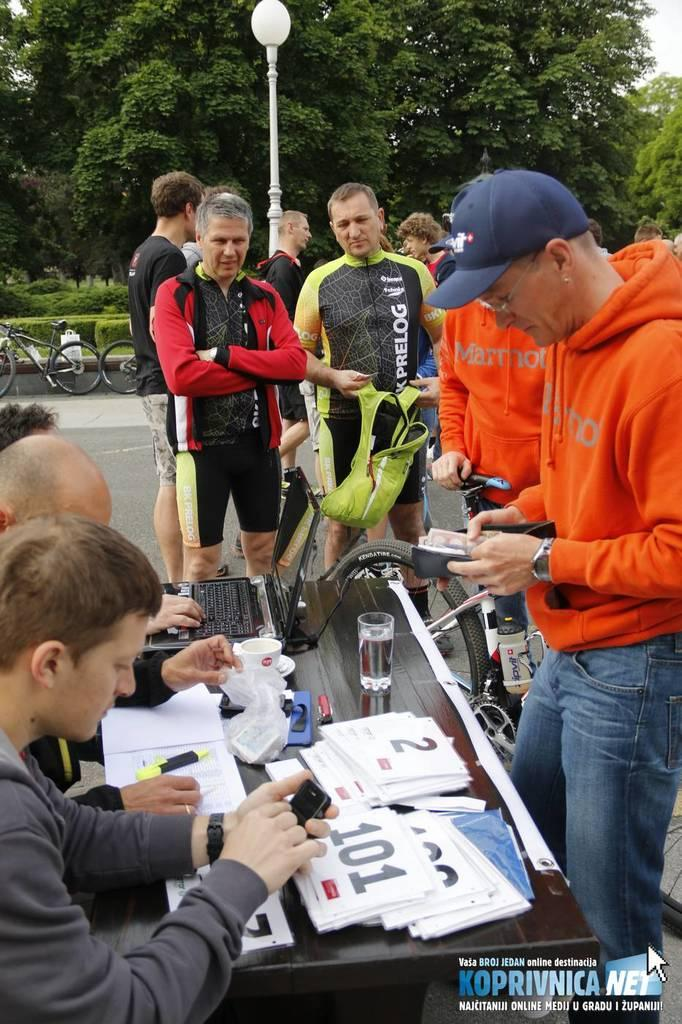What are the persons in the image wearing? The persons in the image are wearing hoodies and jerseys. Where are the persons in the image standing? They are standing in front of a table. What is on the table in the image? There are laptops and cards on the table. What is the position of the persons sitting in the image? The persons sitting are on the left side of the table. What can be seen in the background of the image? Trees are visible in the background of the image. What type of soda is being poured into the laptop in the image? There is no soda present in the image, and no liquid is being poured into the laptop. 